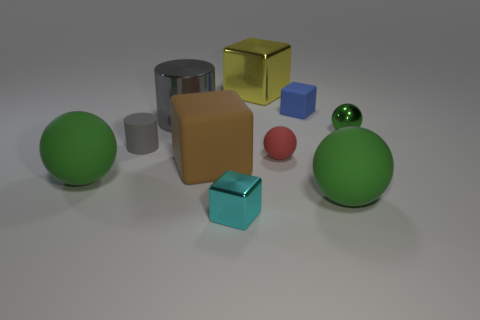There is a tiny shiny object that is in front of the red matte object; does it have the same color as the matte sphere behind the large rubber cube? No, the tiny shiny object in question does not have the same color. The tiny shiny object is silver, whereas the matte sphere is red, indicating a distinct difference in hue and finish between the two objects. 